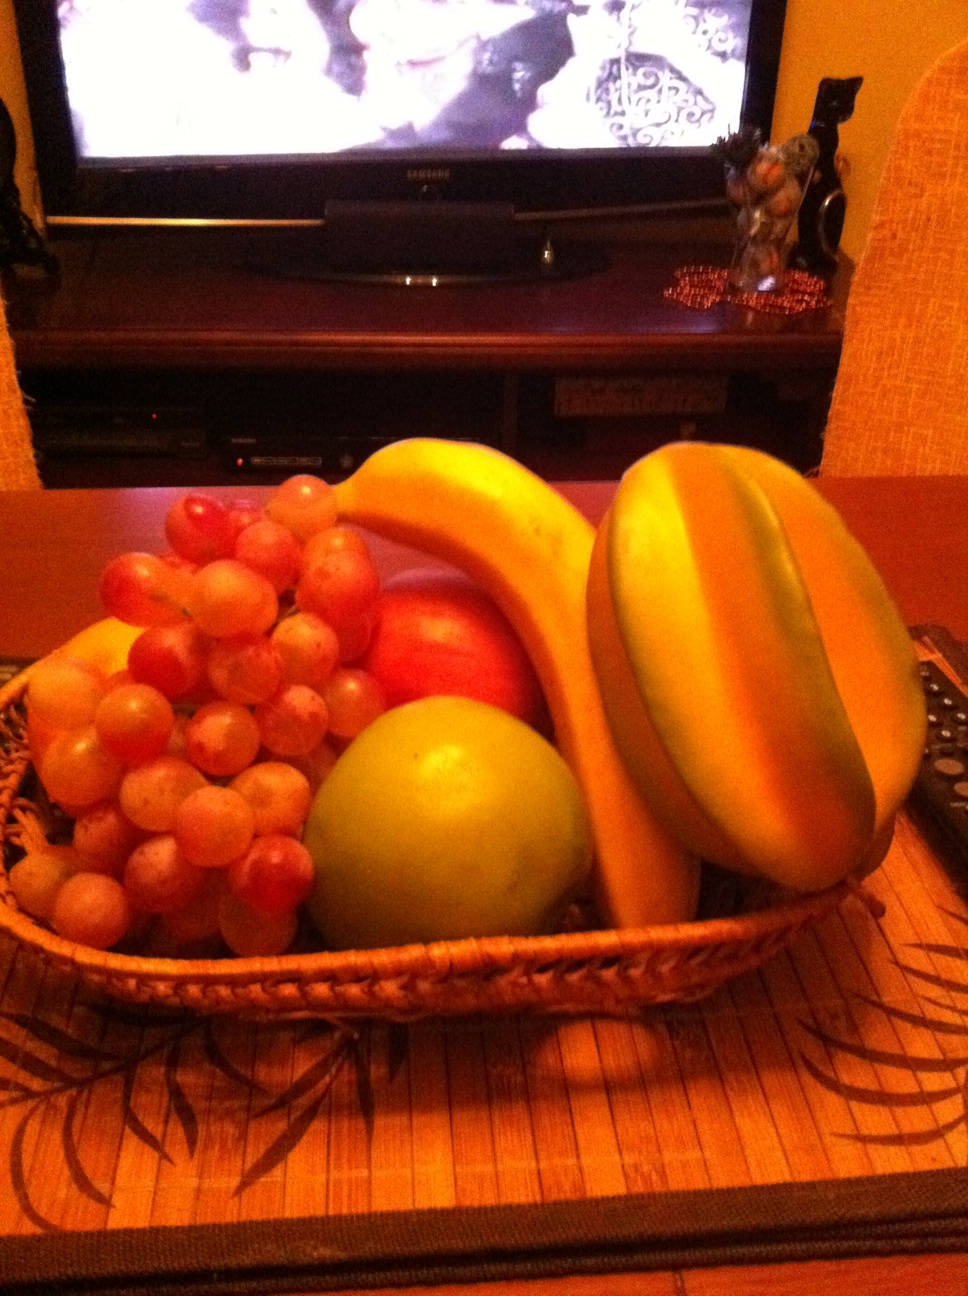Can you tell more about the setting of this image? Certainly! The setting is a warm, inviting room perhaps indicative of a home environment. The fruit basket rests on a sturdy wooden table, and the detailed, patterned placemat suggests a careful attention to decor. In the background, there's a television displaying what might be an older movie or show, adding a nostalgic element to the scene. 